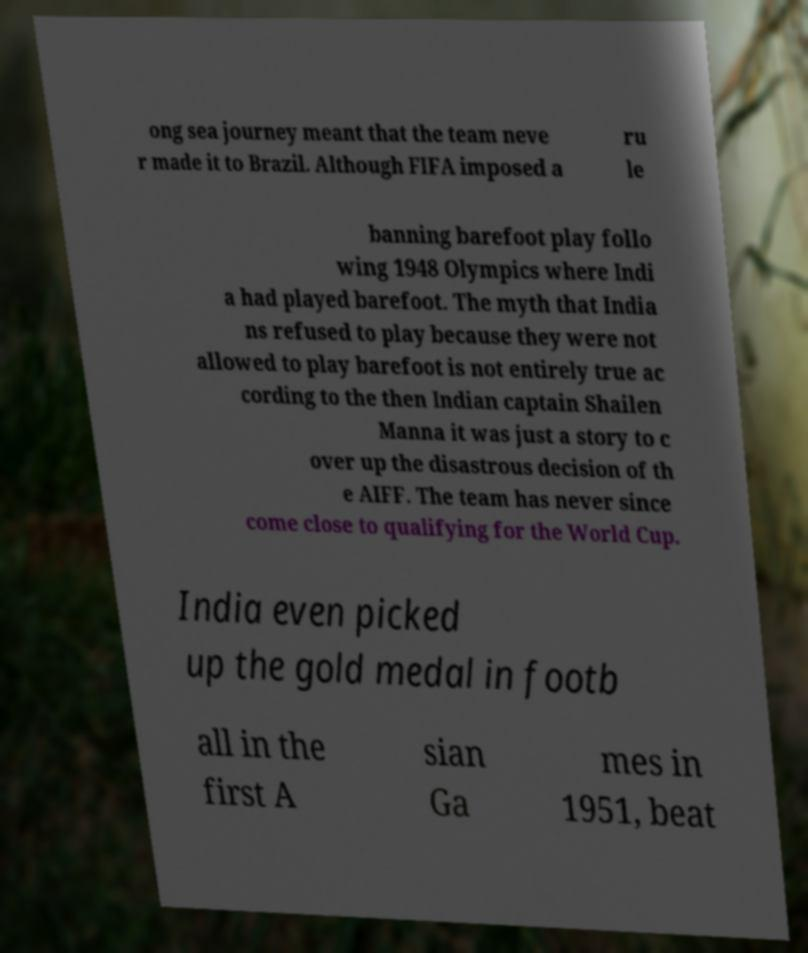Please identify and transcribe the text found in this image. ong sea journey meant that the team neve r made it to Brazil. Although FIFA imposed a ru le banning barefoot play follo wing 1948 Olympics where Indi a had played barefoot. The myth that India ns refused to play because they were not allowed to play barefoot is not entirely true ac cording to the then Indian captain Shailen Manna it was just a story to c over up the disastrous decision of th e AIFF. The team has never since come close to qualifying for the World Cup. India even picked up the gold medal in footb all in the first A sian Ga mes in 1951, beat 